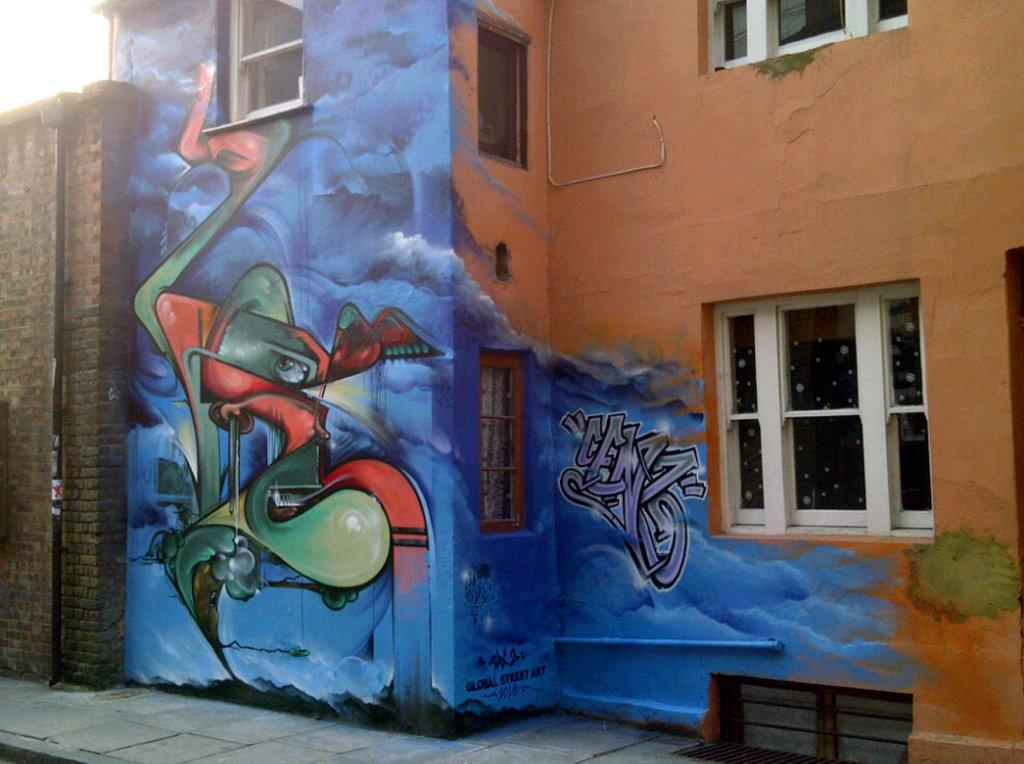What color is the house in the image? The house is orange-colored in the image. What decoration can be seen on the house? There is a blue and green dragon painted on the house using spray. Can you describe the window on the house? There is a white-colored window on the right side of the house. What type of wall is on the left side of the house? There is a brick wall on the left side of the house. What type of stew is being cooked in the image? There is no stew present in the image; it features an orange-colored house with a dragon painting, a white window, and a brick wall. How many cabbages are visible in the image? There are no cabbages present in the image. 